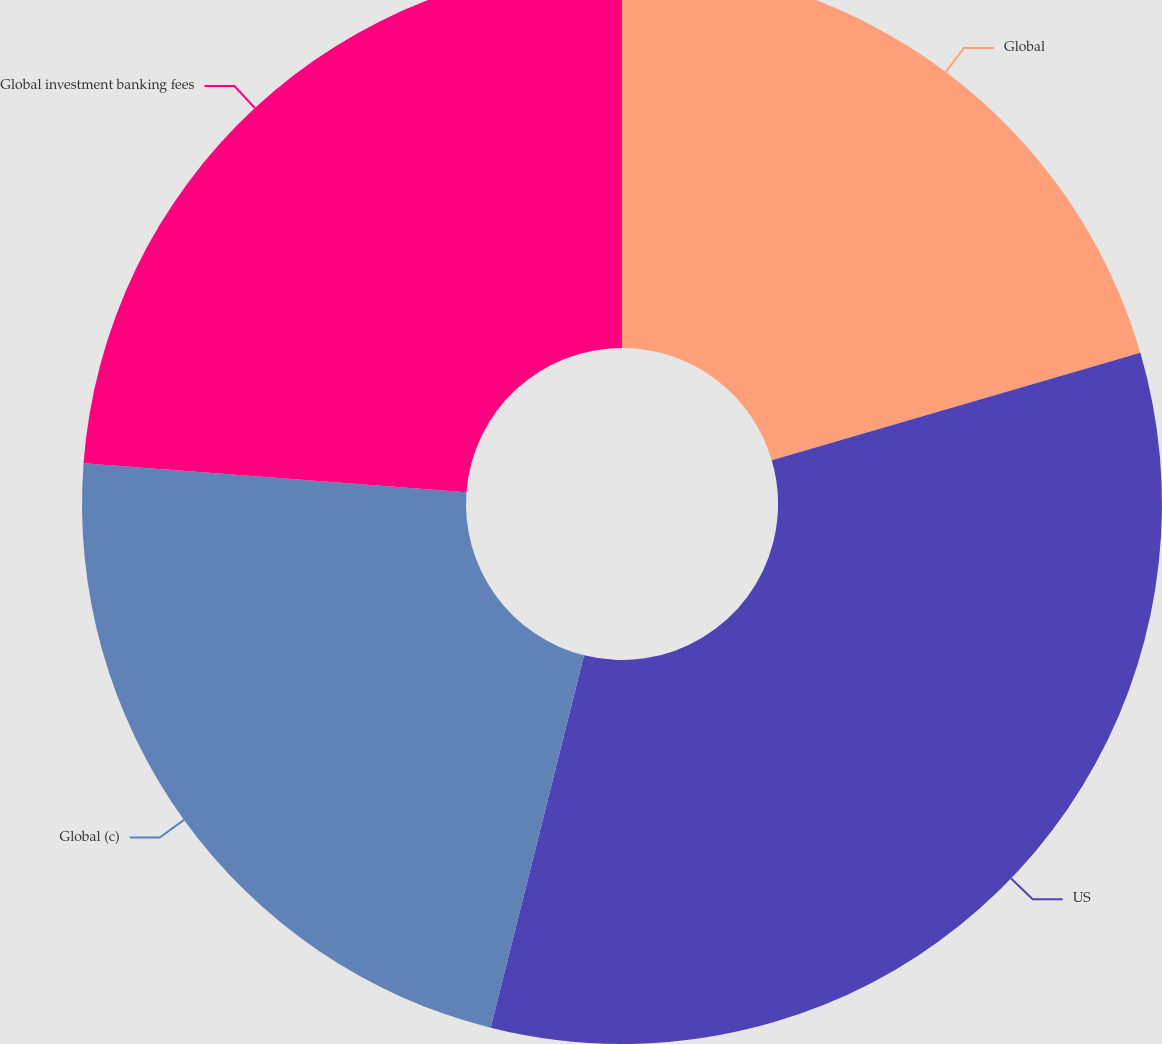Convert chart. <chart><loc_0><loc_0><loc_500><loc_500><pie_chart><fcel>Global<fcel>US<fcel>Global (c)<fcel>Global investment banking fees<nl><fcel>20.48%<fcel>33.43%<fcel>22.29%<fcel>23.8%<nl></chart> 